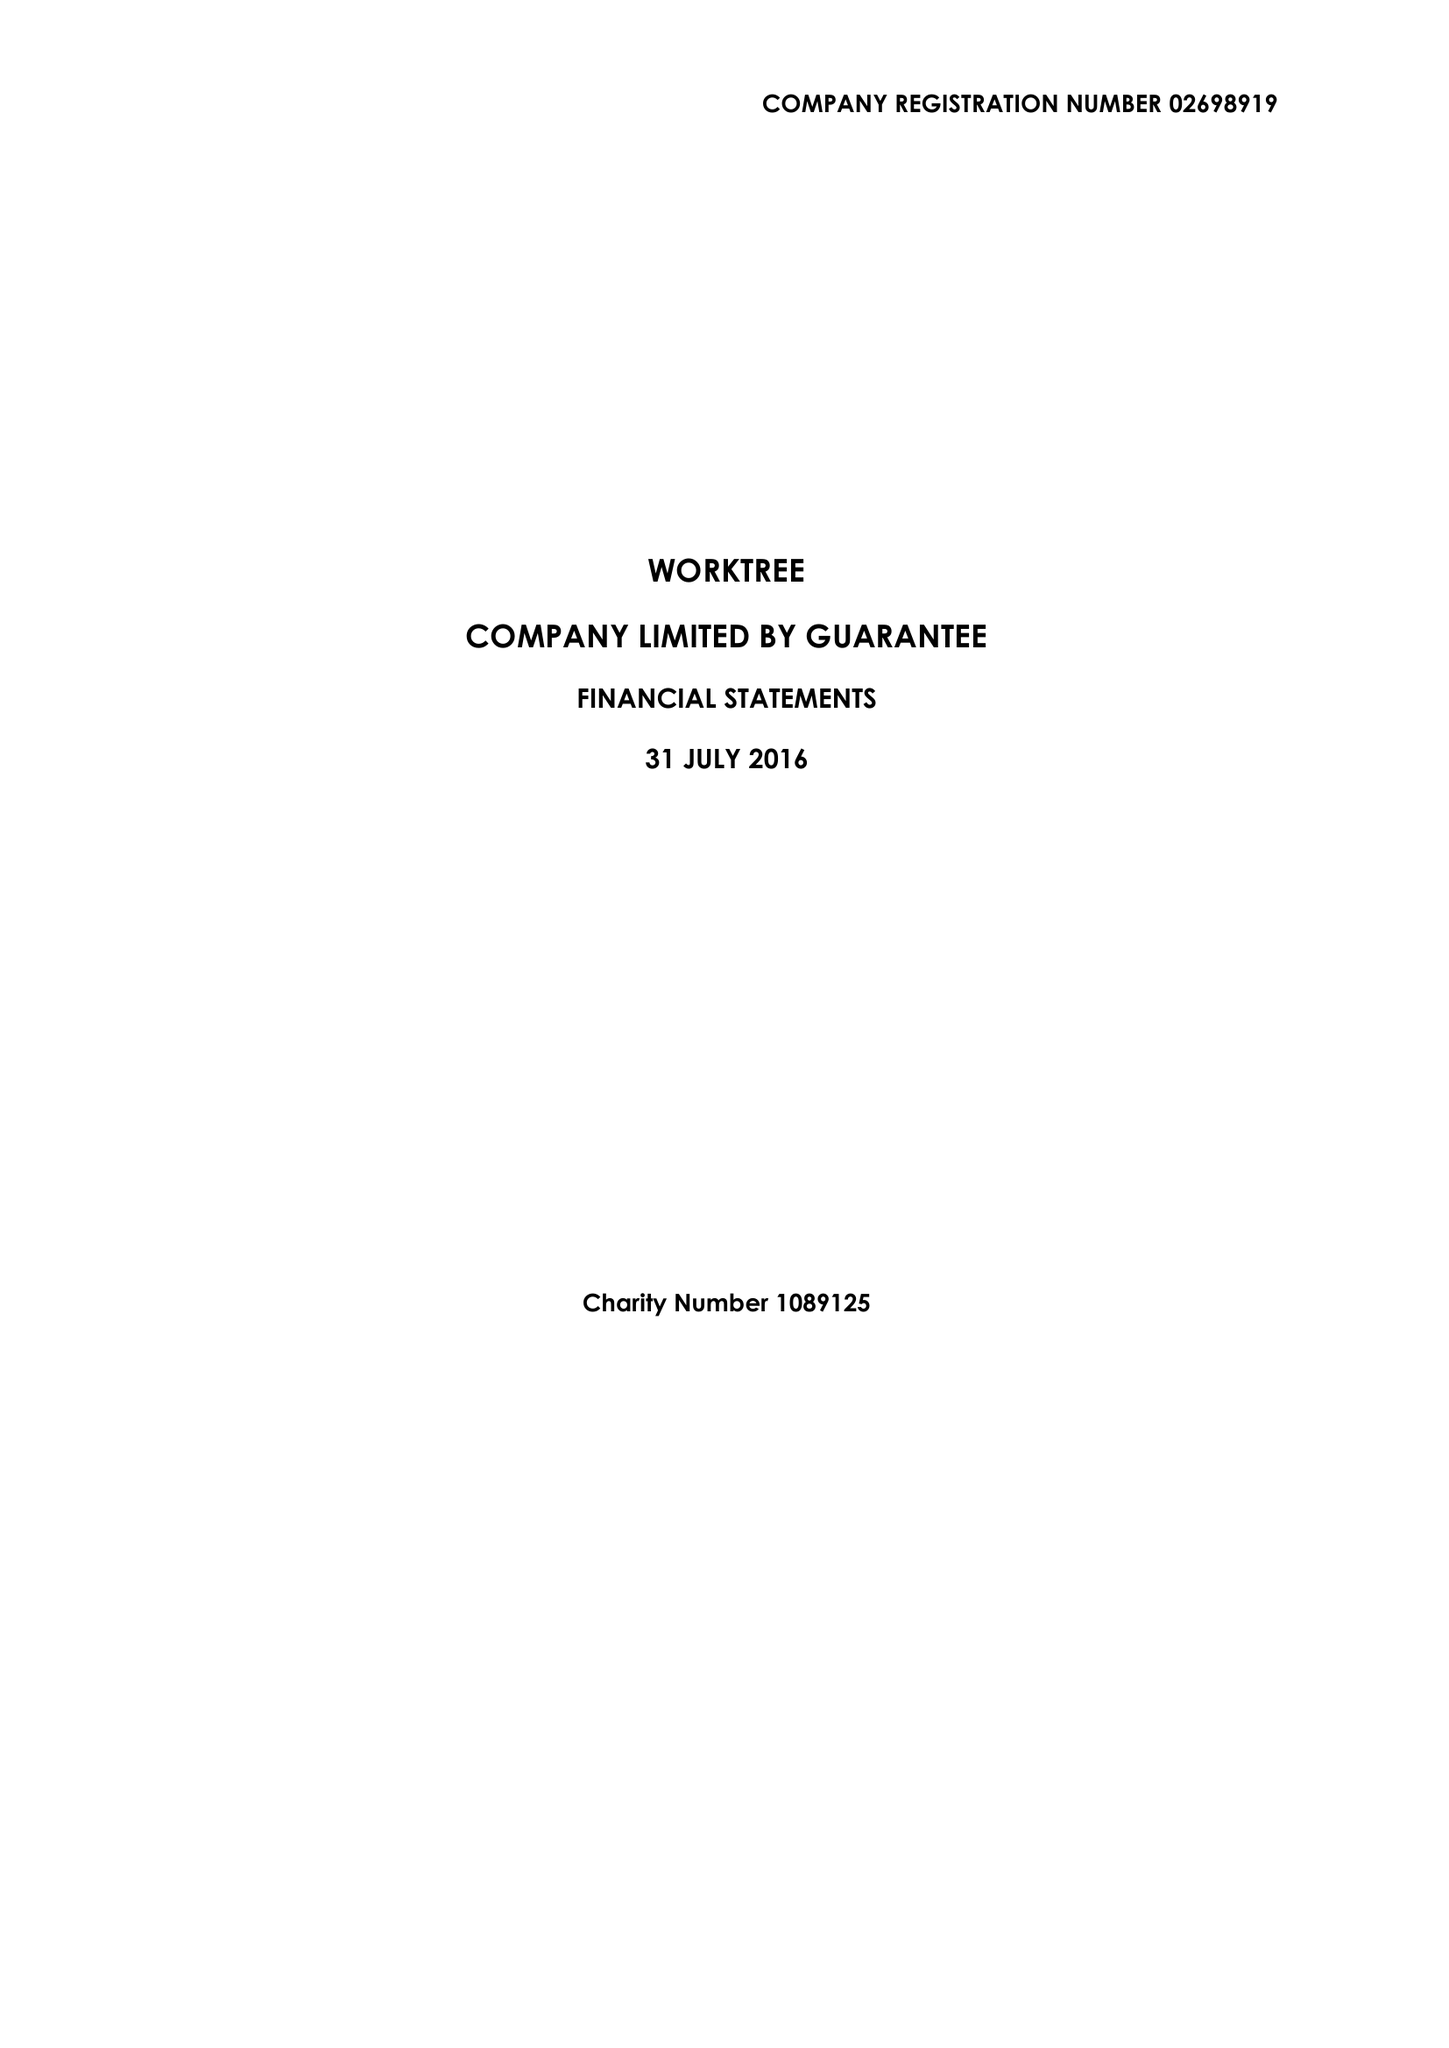What is the value for the spending_annually_in_british_pounds?
Answer the question using a single word or phrase. 66718.00 